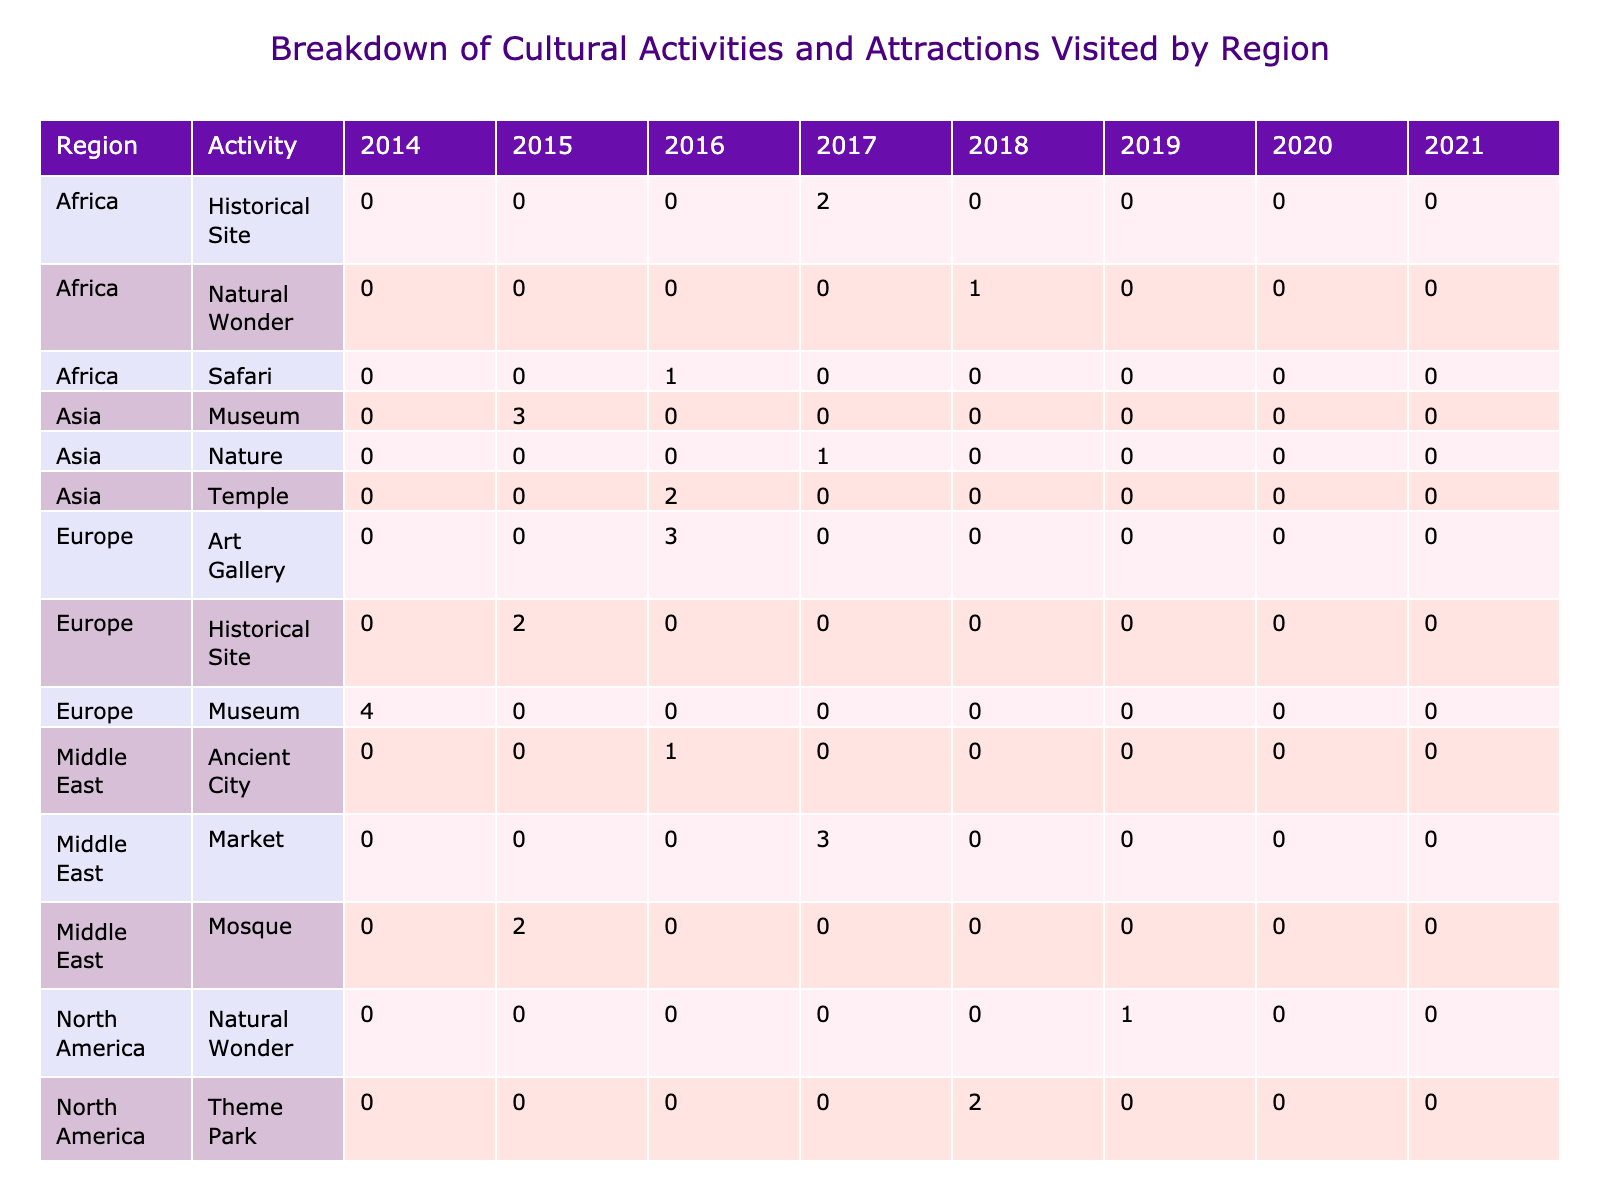What region has the highest number of visits for museums? Looking at the 'Museum' activities across the various regions, we find that Europe has a total of 4 visits for the Louvre museum, which is the highest among all other regions.
Answer: Europe What is the total number of visits to nature-related activities across all regions? We can sum the visits for nature activities: Mount Fuji (1), Milford Sound (1), and Victoria Falls (1), which gives us a total of 1 + 1 + 1 = 3 visits.
Answer: 3 Which activity had the least number of visits in South America? In South America, the 'Historical Site' category for Machu Picchu has just 1 visit, which is the lowest among its activities (Carnival and Beach both have more).
Answer: Historical Site Did any region have visits for both museums and historical sites? Yes, Europe had visits for both museums (Louvre) and historical sites (Colosseum). This shows that Europe engages in both types of cultural activities.
Answer: Yes What is the average number of visits for urban landmarks across all regions? For urban landmarks, the visits are Statue of Liberty (3), Sydney Opera House (3). Adding these gives 3 + 3 = 6. Dividing by the number of urban landmarks, which is 2, results in an average of 6 / 2 = 3.
Answer: 3 How many more visits did North America have for theme parks than for natural wonders? North America had 2 visits for theme parks (Disneyland) and 1 visit for natural wonders (Grand Canyon). Therefore, 2 - 1 = 1 more visit for theme parks.
Answer: 1 Which region has the second most visits to cultural activities? By checking the total visits for each region: Europe (9), North America (6), Asia (6), South America (4), Africa (4), Oceania (6), and Middle East (6). Asia and North America both have 6 visits, but we are looking for the second place, which is Asia.
Answer: Asia Was the Grand Bazaar visited more times than the Grand Canyon? The Grand Bazaar had 3 visits, while the Grand Canyon had 1 visit. Thus, the Grand Bazaar was visited more times than the Grand Canyon.
Answer: Yes How many unique activities are recorded for the Middle East region? The Middle East has 3 unique activities: Mosque, Ancient City, and Market. Therefore, there are 3 unique activities recorded for this region.
Answer: 3 